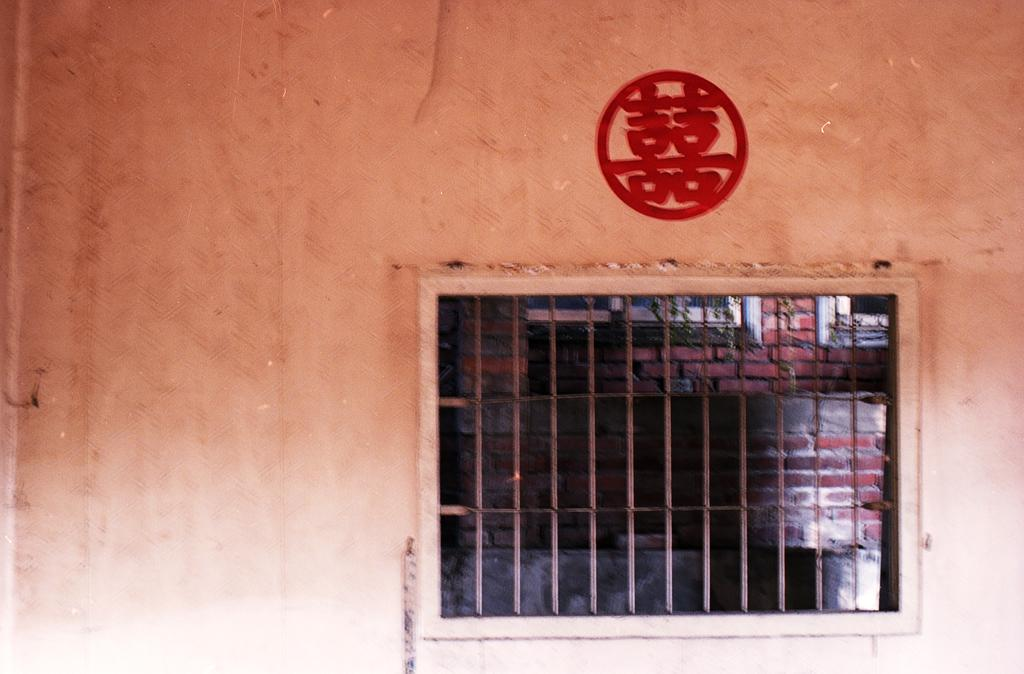What is on the wall in the image? There is a symbol on the wall in the image. What architectural feature is present in the image? There is a window in the image. What can be seen through the window? There is a wall visible through the window, and there are also windows visible through the window. What word is written on the wall in the image? There is no word written on the wall in the image; it only features a symbol. Can you see any cherries hanging from the windows in the image? There are no cherries present in the image. 